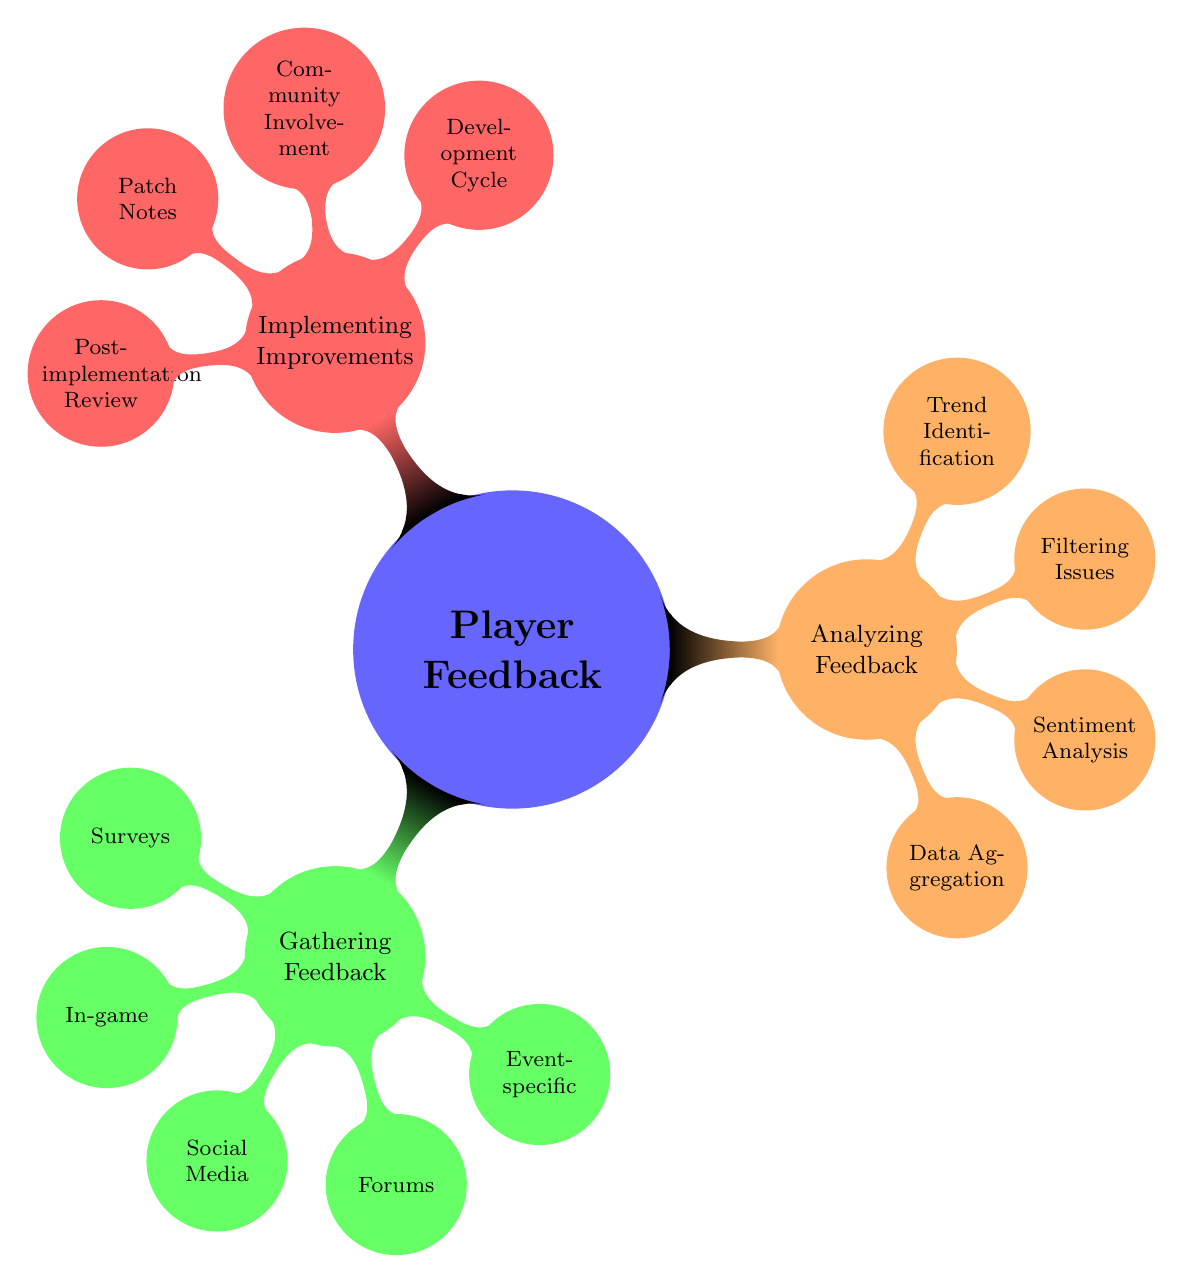What are the three main categories of player feedback? The diagram outlines three main categories: Gathering Feedback, Analyzing Feedback, and Implementing Improvements. These are the primary areas focused on in player feedback processes.
Answer: Gathering Feedback, Analyzing Feedback, Implementing Improvements How many types of Gathering Feedback are listed? There are five distinct types of Gathering Feedback identified in the diagram: Surveys and Polls, In-game Feedback, Social Media, Community Forums, and Event-specific Feedback. By counting these nodes, we determine the total.
Answer: 5 Which tool is associated with Sentiment Analysis? The diagram indicates two tools for Sentiment Analysis: Lexalytics and MonkeyLearn. Since the question asks for the association, we can select either tool from the node.
Answer: Lexalytics What node is connected directly to Community Involvement? The node directly connected to Community Involvement is Beta Testing Groups. This is the specific improvement initiative listed under the Implementing Improvements category.
Answer: Beta Testing Groups Which category does Post-implementation Review belong to? Post-implementation Review is categorized under Implementing Improvements. By tracing the node's connection, we can identify the category it is associated with.
Answer: Implementing Improvements List one method of Data Aggregation mentioned in the diagram. The diagram specifies Excel and Google Sheets as tools for Data Aggregation. As the question asks for one method, we can provide just one of these options from the corresponding node.
Answer: Excel How many nodes are under Analyzing Feedback? The diagram shows four nodes under Analyzing Feedback: Data Aggregation, Sentiment Analysis, Filtering Key Issues, and Trend Identification. By counting these nodes, we find the total.
Answer: 4 What relationship exists between Gathering Feedback and Analyzing Feedback? Gathering Feedback leads to Analyzing Feedback in the context of player feedback processes. The diagram suggests that after feedback is gathered, it must be analyzed, establishing a sequential relationship.
Answer: Sequential Which color represents Implementing Improvements in the diagram? Implementing Improvements is represented by the color red according to the color coding used in the diagram for different categories.
Answer: Red 